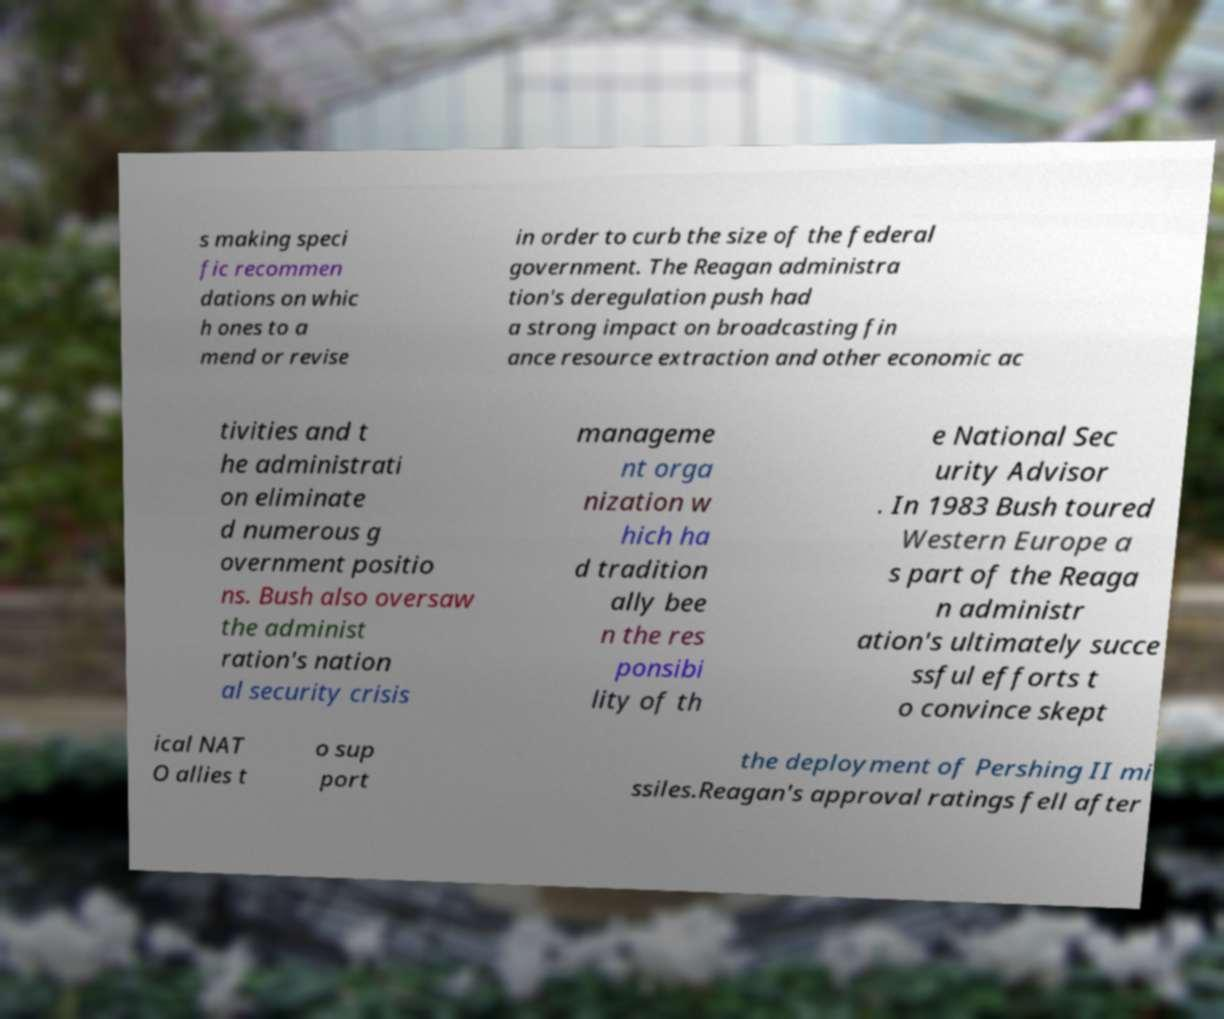Please identify and transcribe the text found in this image. s making speci fic recommen dations on whic h ones to a mend or revise in order to curb the size of the federal government. The Reagan administra tion's deregulation push had a strong impact on broadcasting fin ance resource extraction and other economic ac tivities and t he administrati on eliminate d numerous g overnment positio ns. Bush also oversaw the administ ration's nation al security crisis manageme nt orga nization w hich ha d tradition ally bee n the res ponsibi lity of th e National Sec urity Advisor . In 1983 Bush toured Western Europe a s part of the Reaga n administr ation's ultimately succe ssful efforts t o convince skept ical NAT O allies t o sup port the deployment of Pershing II mi ssiles.Reagan's approval ratings fell after 